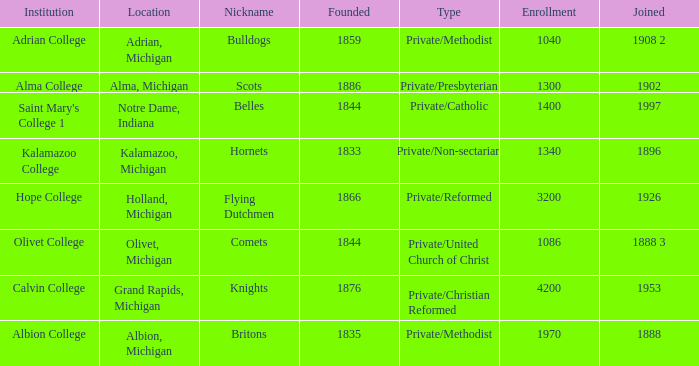Which categories fit under the institution calvin college? Private/Christian Reformed. 